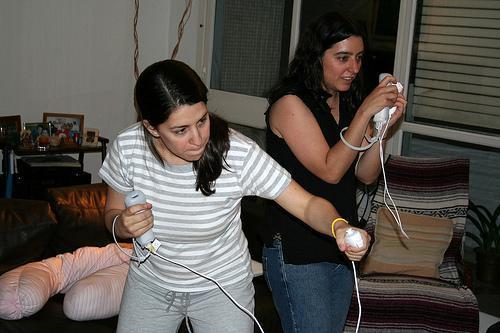How many girls are there?
Give a very brief answer. 2. 